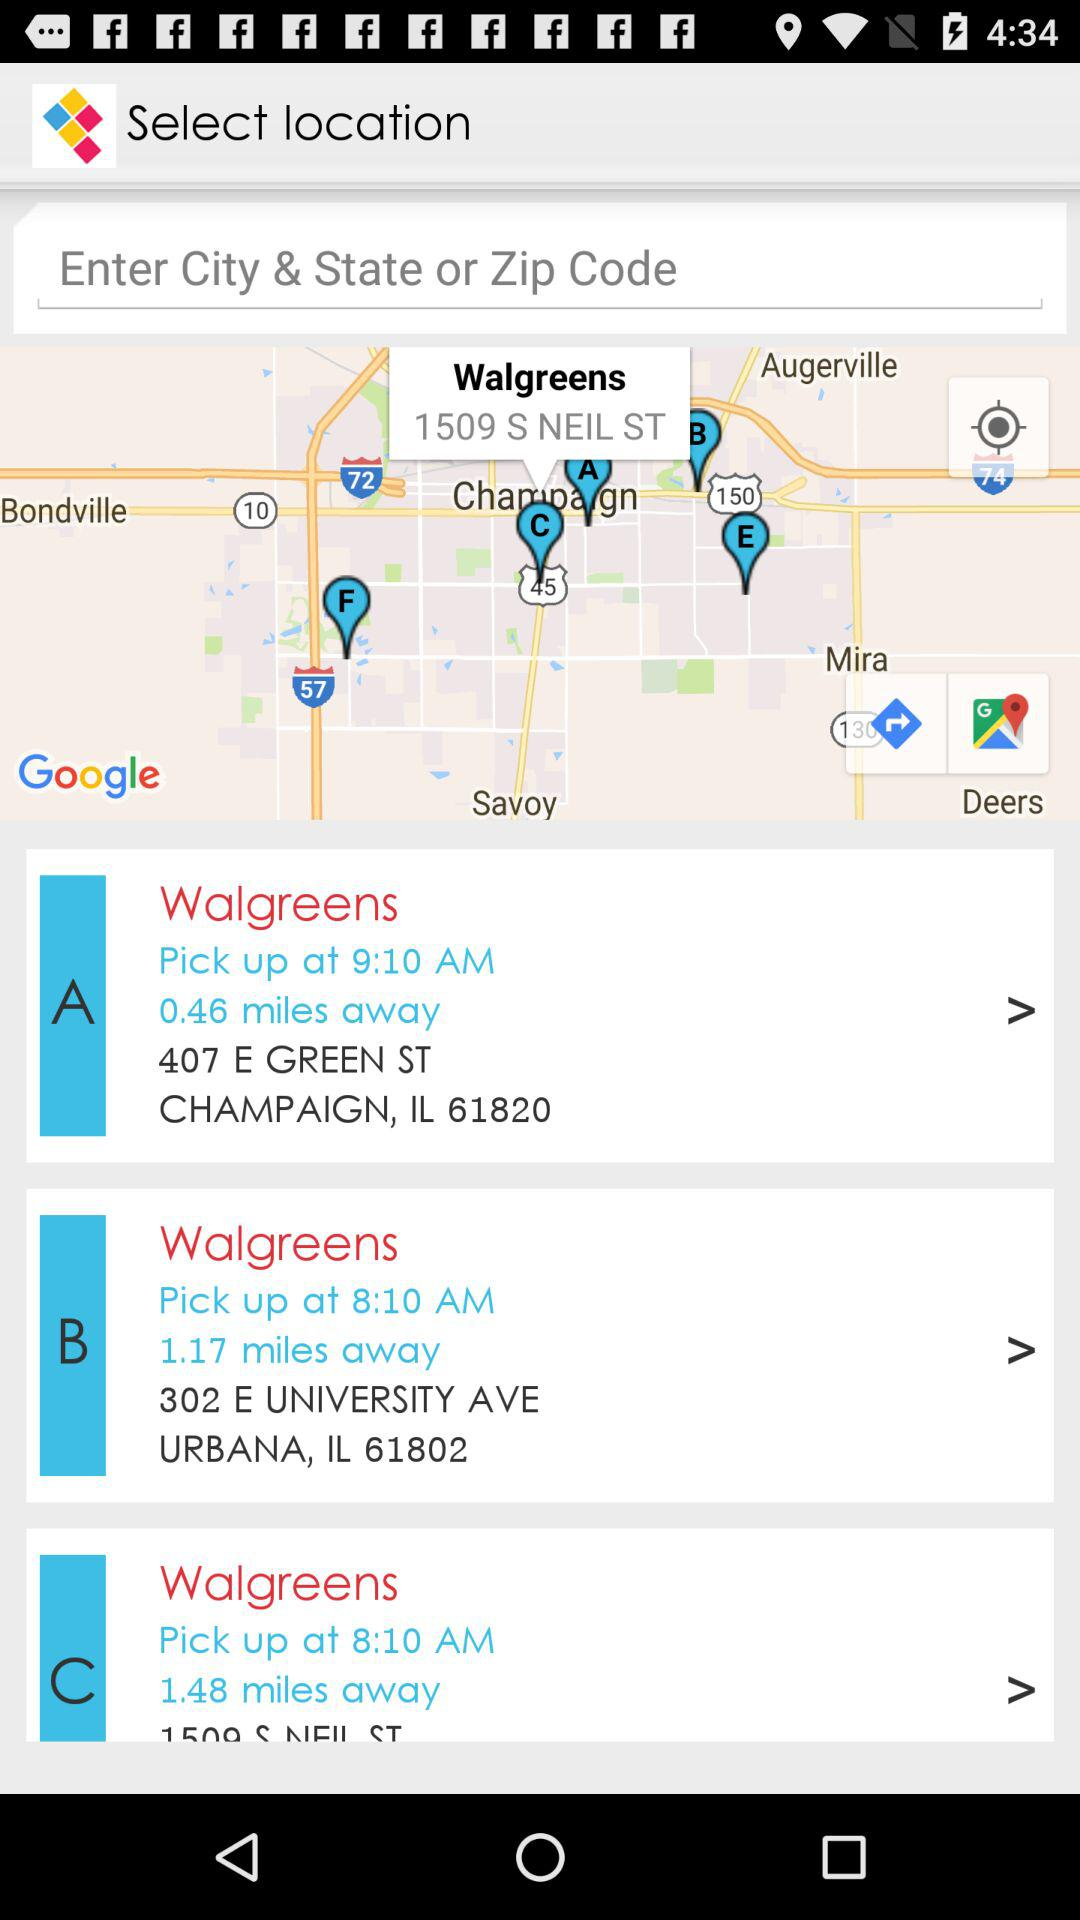Which is the location of "A"? The location of "A" is 407 E Green St., Champaign, IL 61820. 